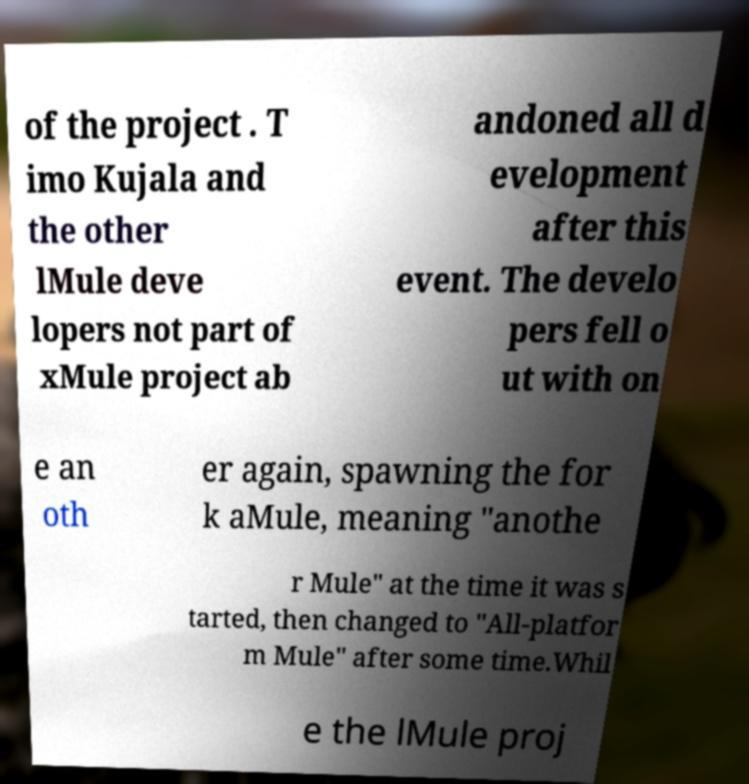Please identify and transcribe the text found in this image. of the project . T imo Kujala and the other lMule deve lopers not part of xMule project ab andoned all d evelopment after this event. The develo pers fell o ut with on e an oth er again, spawning the for k aMule, meaning "anothe r Mule" at the time it was s tarted, then changed to "All-platfor m Mule" after some time.Whil e the lMule proj 